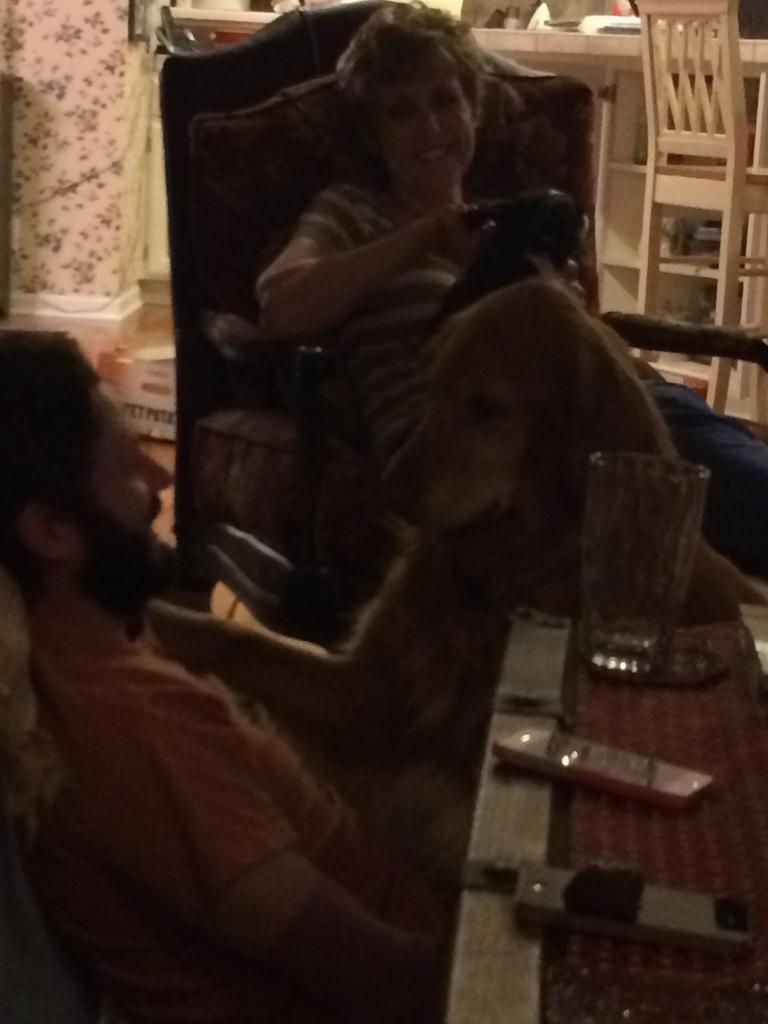How many people are sitting in chairs in the image? There are two people sitting in chairs in the image. What is in front of the chairs? The chairs are in front of a table. What can be seen on the table? There are mobiles and a glass on the table. What is visible in the background? There is a chair and a wall in the background. What type of leaf is falling from the sun in the image? There is no leaf or sun present in the image. 